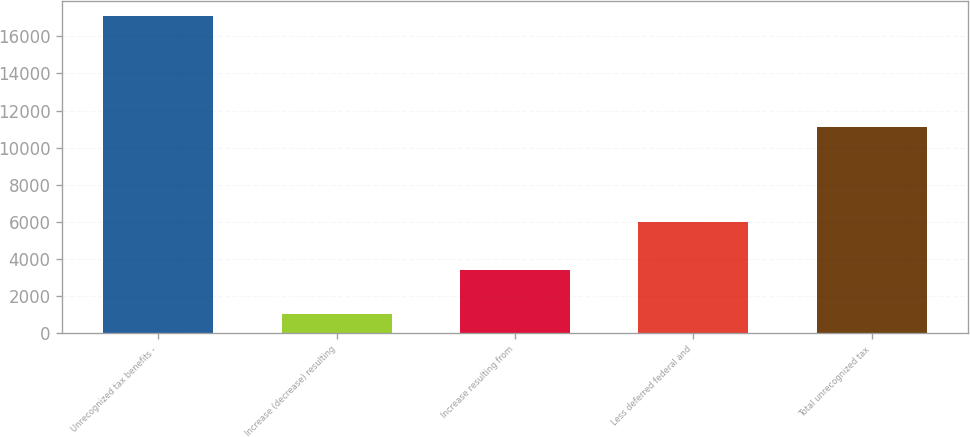<chart> <loc_0><loc_0><loc_500><loc_500><bar_chart><fcel>Unrecognized tax benefits -<fcel>Increase (decrease) resulting<fcel>Increase resulting from<fcel>Less deferred federal and<fcel>Total unrecognized tax<nl><fcel>17069<fcel>1009<fcel>3431<fcel>5974<fcel>11095<nl></chart> 